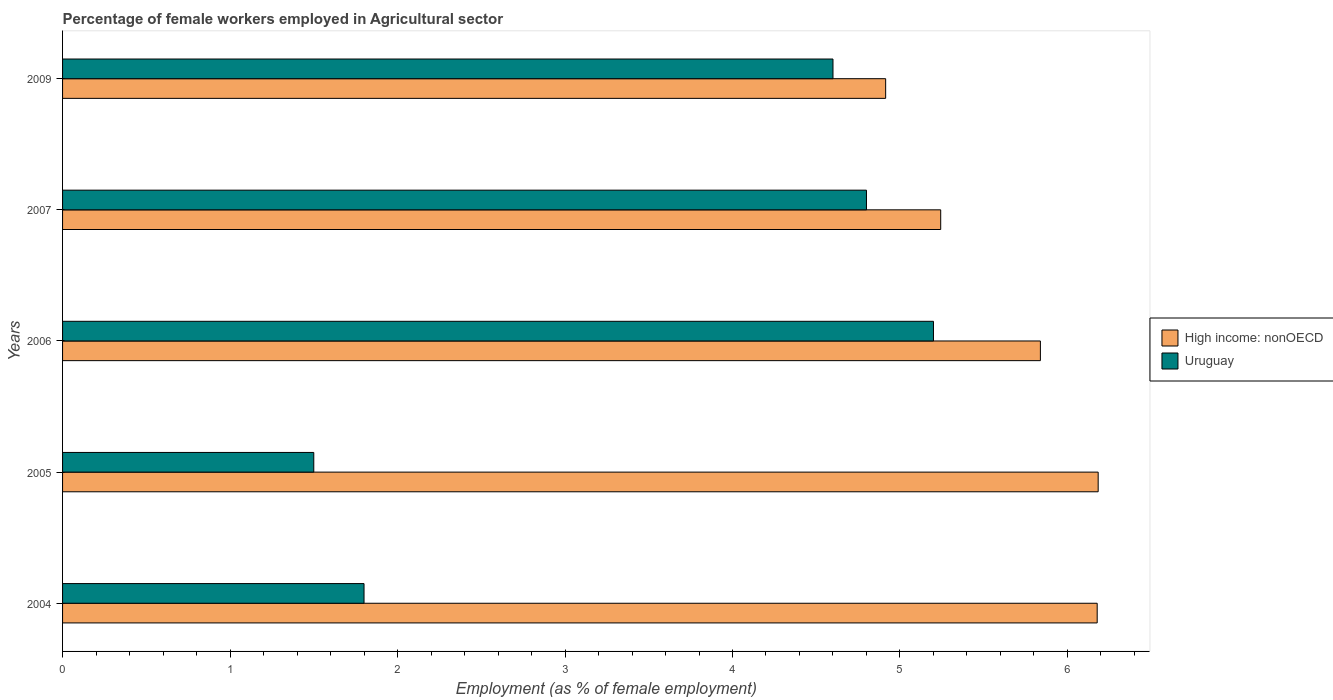How many different coloured bars are there?
Keep it short and to the point. 2. Are the number of bars per tick equal to the number of legend labels?
Provide a succinct answer. Yes. Are the number of bars on each tick of the Y-axis equal?
Offer a terse response. Yes. How many bars are there on the 4th tick from the top?
Offer a terse response. 2. What is the label of the 2nd group of bars from the top?
Provide a succinct answer. 2007. In how many cases, is the number of bars for a given year not equal to the number of legend labels?
Give a very brief answer. 0. What is the percentage of females employed in Agricultural sector in Uruguay in 2009?
Give a very brief answer. 4.6. Across all years, what is the maximum percentage of females employed in Agricultural sector in High income: nonOECD?
Offer a very short reply. 6.18. Across all years, what is the minimum percentage of females employed in Agricultural sector in High income: nonOECD?
Your answer should be compact. 4.91. In which year was the percentage of females employed in Agricultural sector in High income: nonOECD maximum?
Provide a succinct answer. 2005. What is the total percentage of females employed in Agricultural sector in High income: nonOECD in the graph?
Offer a terse response. 28.36. What is the difference between the percentage of females employed in Agricultural sector in Uruguay in 2004 and that in 2006?
Offer a very short reply. -3.4. What is the difference between the percentage of females employed in Agricultural sector in Uruguay in 2004 and the percentage of females employed in Agricultural sector in High income: nonOECD in 2006?
Make the answer very short. -4.04. What is the average percentage of females employed in Agricultural sector in Uruguay per year?
Your answer should be compact. 3.58. In the year 2005, what is the difference between the percentage of females employed in Agricultural sector in Uruguay and percentage of females employed in Agricultural sector in High income: nonOECD?
Keep it short and to the point. -4.68. In how many years, is the percentage of females employed in Agricultural sector in Uruguay greater than 1.6 %?
Offer a terse response. 4. What is the ratio of the percentage of females employed in Agricultural sector in High income: nonOECD in 2004 to that in 2005?
Provide a succinct answer. 1. Is the percentage of females employed in Agricultural sector in Uruguay in 2006 less than that in 2007?
Provide a short and direct response. No. What is the difference between the highest and the second highest percentage of females employed in Agricultural sector in Uruguay?
Ensure brevity in your answer.  0.4. What is the difference between the highest and the lowest percentage of females employed in Agricultural sector in High income: nonOECD?
Offer a very short reply. 1.27. What does the 2nd bar from the top in 2006 represents?
Your answer should be compact. High income: nonOECD. What does the 1st bar from the bottom in 2006 represents?
Your response must be concise. High income: nonOECD. Are all the bars in the graph horizontal?
Ensure brevity in your answer.  Yes. Does the graph contain grids?
Make the answer very short. No. Where does the legend appear in the graph?
Keep it short and to the point. Center right. How many legend labels are there?
Keep it short and to the point. 2. How are the legend labels stacked?
Ensure brevity in your answer.  Vertical. What is the title of the graph?
Keep it short and to the point. Percentage of female workers employed in Agricultural sector. What is the label or title of the X-axis?
Provide a succinct answer. Employment (as % of female employment). What is the Employment (as % of female employment) of High income: nonOECD in 2004?
Provide a succinct answer. 6.18. What is the Employment (as % of female employment) in Uruguay in 2004?
Your response must be concise. 1.8. What is the Employment (as % of female employment) of High income: nonOECD in 2005?
Offer a terse response. 6.18. What is the Employment (as % of female employment) in Uruguay in 2005?
Keep it short and to the point. 1.5. What is the Employment (as % of female employment) of High income: nonOECD in 2006?
Keep it short and to the point. 5.84. What is the Employment (as % of female employment) in Uruguay in 2006?
Your answer should be compact. 5.2. What is the Employment (as % of female employment) in High income: nonOECD in 2007?
Make the answer very short. 5.24. What is the Employment (as % of female employment) of Uruguay in 2007?
Your response must be concise. 4.8. What is the Employment (as % of female employment) in High income: nonOECD in 2009?
Offer a very short reply. 4.91. What is the Employment (as % of female employment) of Uruguay in 2009?
Provide a short and direct response. 4.6. Across all years, what is the maximum Employment (as % of female employment) of High income: nonOECD?
Keep it short and to the point. 6.18. Across all years, what is the maximum Employment (as % of female employment) in Uruguay?
Provide a short and direct response. 5.2. Across all years, what is the minimum Employment (as % of female employment) of High income: nonOECD?
Your response must be concise. 4.91. What is the total Employment (as % of female employment) in High income: nonOECD in the graph?
Keep it short and to the point. 28.36. What is the total Employment (as % of female employment) in Uruguay in the graph?
Keep it short and to the point. 17.9. What is the difference between the Employment (as % of female employment) in High income: nonOECD in 2004 and that in 2005?
Offer a very short reply. -0.01. What is the difference between the Employment (as % of female employment) of Uruguay in 2004 and that in 2005?
Keep it short and to the point. 0.3. What is the difference between the Employment (as % of female employment) in High income: nonOECD in 2004 and that in 2006?
Your answer should be very brief. 0.34. What is the difference between the Employment (as % of female employment) of High income: nonOECD in 2004 and that in 2007?
Provide a short and direct response. 0.93. What is the difference between the Employment (as % of female employment) of High income: nonOECD in 2004 and that in 2009?
Provide a succinct answer. 1.26. What is the difference between the Employment (as % of female employment) of High income: nonOECD in 2005 and that in 2006?
Provide a short and direct response. 0.34. What is the difference between the Employment (as % of female employment) in High income: nonOECD in 2005 and that in 2007?
Make the answer very short. 0.94. What is the difference between the Employment (as % of female employment) in Uruguay in 2005 and that in 2007?
Your answer should be compact. -3.3. What is the difference between the Employment (as % of female employment) in High income: nonOECD in 2005 and that in 2009?
Make the answer very short. 1.27. What is the difference between the Employment (as % of female employment) in Uruguay in 2005 and that in 2009?
Ensure brevity in your answer.  -3.1. What is the difference between the Employment (as % of female employment) of High income: nonOECD in 2006 and that in 2007?
Keep it short and to the point. 0.6. What is the difference between the Employment (as % of female employment) of High income: nonOECD in 2006 and that in 2009?
Offer a very short reply. 0.92. What is the difference between the Employment (as % of female employment) in High income: nonOECD in 2007 and that in 2009?
Give a very brief answer. 0.33. What is the difference between the Employment (as % of female employment) of High income: nonOECD in 2004 and the Employment (as % of female employment) of Uruguay in 2005?
Offer a terse response. 4.68. What is the difference between the Employment (as % of female employment) in High income: nonOECD in 2004 and the Employment (as % of female employment) in Uruguay in 2006?
Offer a very short reply. 0.98. What is the difference between the Employment (as % of female employment) in High income: nonOECD in 2004 and the Employment (as % of female employment) in Uruguay in 2007?
Ensure brevity in your answer.  1.38. What is the difference between the Employment (as % of female employment) in High income: nonOECD in 2004 and the Employment (as % of female employment) in Uruguay in 2009?
Give a very brief answer. 1.58. What is the difference between the Employment (as % of female employment) in High income: nonOECD in 2005 and the Employment (as % of female employment) in Uruguay in 2006?
Keep it short and to the point. 0.98. What is the difference between the Employment (as % of female employment) in High income: nonOECD in 2005 and the Employment (as % of female employment) in Uruguay in 2007?
Your answer should be very brief. 1.38. What is the difference between the Employment (as % of female employment) in High income: nonOECD in 2005 and the Employment (as % of female employment) in Uruguay in 2009?
Offer a very short reply. 1.58. What is the difference between the Employment (as % of female employment) in High income: nonOECD in 2006 and the Employment (as % of female employment) in Uruguay in 2007?
Your answer should be compact. 1.04. What is the difference between the Employment (as % of female employment) of High income: nonOECD in 2006 and the Employment (as % of female employment) of Uruguay in 2009?
Give a very brief answer. 1.24. What is the difference between the Employment (as % of female employment) of High income: nonOECD in 2007 and the Employment (as % of female employment) of Uruguay in 2009?
Keep it short and to the point. 0.64. What is the average Employment (as % of female employment) in High income: nonOECD per year?
Keep it short and to the point. 5.67. What is the average Employment (as % of female employment) of Uruguay per year?
Your response must be concise. 3.58. In the year 2004, what is the difference between the Employment (as % of female employment) of High income: nonOECD and Employment (as % of female employment) of Uruguay?
Make the answer very short. 4.38. In the year 2005, what is the difference between the Employment (as % of female employment) in High income: nonOECD and Employment (as % of female employment) in Uruguay?
Your answer should be compact. 4.68. In the year 2006, what is the difference between the Employment (as % of female employment) of High income: nonOECD and Employment (as % of female employment) of Uruguay?
Offer a very short reply. 0.64. In the year 2007, what is the difference between the Employment (as % of female employment) in High income: nonOECD and Employment (as % of female employment) in Uruguay?
Provide a succinct answer. 0.44. In the year 2009, what is the difference between the Employment (as % of female employment) in High income: nonOECD and Employment (as % of female employment) in Uruguay?
Ensure brevity in your answer.  0.31. What is the ratio of the Employment (as % of female employment) in High income: nonOECD in 2004 to that in 2005?
Ensure brevity in your answer.  1. What is the ratio of the Employment (as % of female employment) of High income: nonOECD in 2004 to that in 2006?
Give a very brief answer. 1.06. What is the ratio of the Employment (as % of female employment) in Uruguay in 2004 to that in 2006?
Offer a terse response. 0.35. What is the ratio of the Employment (as % of female employment) in High income: nonOECD in 2004 to that in 2007?
Your answer should be compact. 1.18. What is the ratio of the Employment (as % of female employment) in Uruguay in 2004 to that in 2007?
Provide a succinct answer. 0.38. What is the ratio of the Employment (as % of female employment) of High income: nonOECD in 2004 to that in 2009?
Your answer should be very brief. 1.26. What is the ratio of the Employment (as % of female employment) in Uruguay in 2004 to that in 2009?
Your answer should be compact. 0.39. What is the ratio of the Employment (as % of female employment) of High income: nonOECD in 2005 to that in 2006?
Keep it short and to the point. 1.06. What is the ratio of the Employment (as % of female employment) in Uruguay in 2005 to that in 2006?
Provide a short and direct response. 0.29. What is the ratio of the Employment (as % of female employment) of High income: nonOECD in 2005 to that in 2007?
Provide a succinct answer. 1.18. What is the ratio of the Employment (as % of female employment) in Uruguay in 2005 to that in 2007?
Your answer should be very brief. 0.31. What is the ratio of the Employment (as % of female employment) in High income: nonOECD in 2005 to that in 2009?
Your answer should be very brief. 1.26. What is the ratio of the Employment (as % of female employment) in Uruguay in 2005 to that in 2009?
Offer a very short reply. 0.33. What is the ratio of the Employment (as % of female employment) of High income: nonOECD in 2006 to that in 2007?
Offer a terse response. 1.11. What is the ratio of the Employment (as % of female employment) in Uruguay in 2006 to that in 2007?
Keep it short and to the point. 1.08. What is the ratio of the Employment (as % of female employment) in High income: nonOECD in 2006 to that in 2009?
Provide a succinct answer. 1.19. What is the ratio of the Employment (as % of female employment) in Uruguay in 2006 to that in 2009?
Your answer should be very brief. 1.13. What is the ratio of the Employment (as % of female employment) of High income: nonOECD in 2007 to that in 2009?
Ensure brevity in your answer.  1.07. What is the ratio of the Employment (as % of female employment) of Uruguay in 2007 to that in 2009?
Offer a terse response. 1.04. What is the difference between the highest and the second highest Employment (as % of female employment) in High income: nonOECD?
Provide a succinct answer. 0.01. What is the difference between the highest and the lowest Employment (as % of female employment) in High income: nonOECD?
Give a very brief answer. 1.27. 